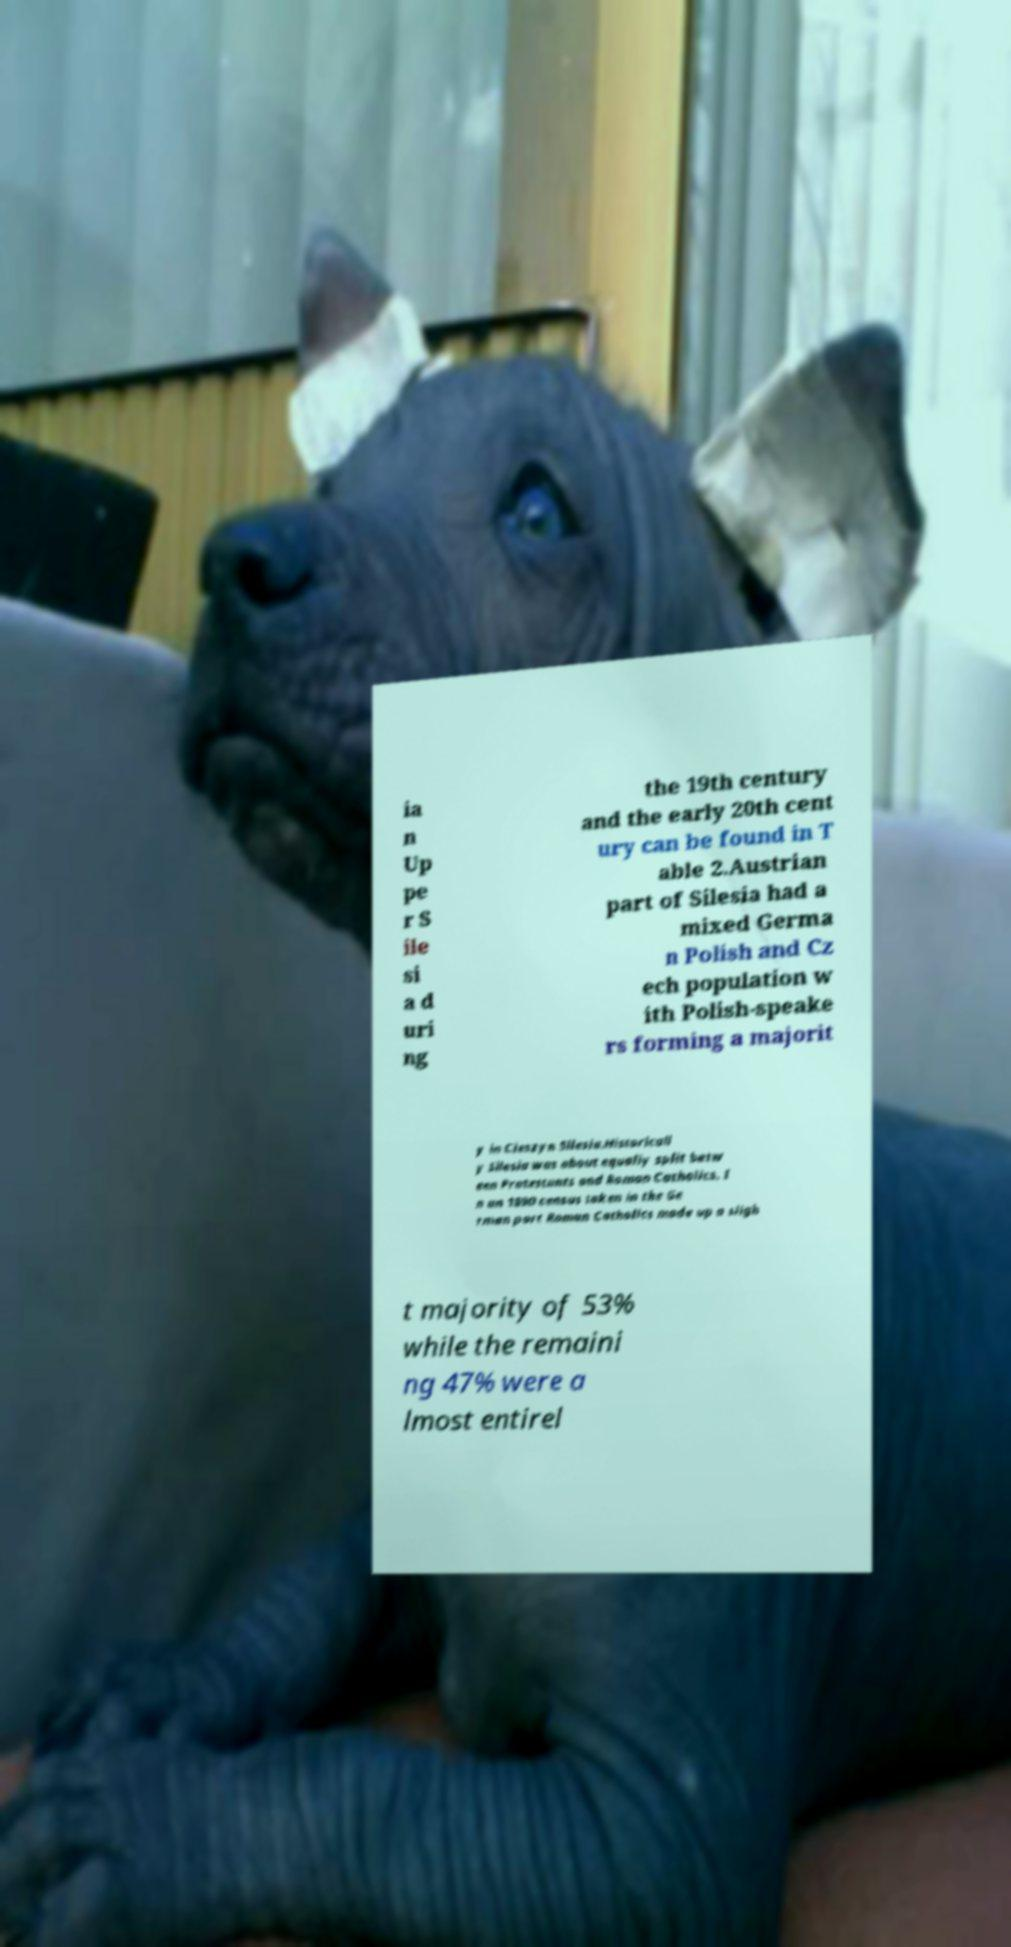I need the written content from this picture converted into text. Can you do that? ia n Up pe r S ile si a d uri ng the 19th century and the early 20th cent ury can be found in T able 2.Austrian part of Silesia had a mixed Germa n Polish and Cz ech population w ith Polish-speake rs forming a majorit y in Cieszyn Silesia.Historicall y Silesia was about equally split betw een Protestants and Roman Catholics. I n an 1890 census taken in the Ge rman part Roman Catholics made up a sligh t majority of 53% while the remaini ng 47% were a lmost entirel 